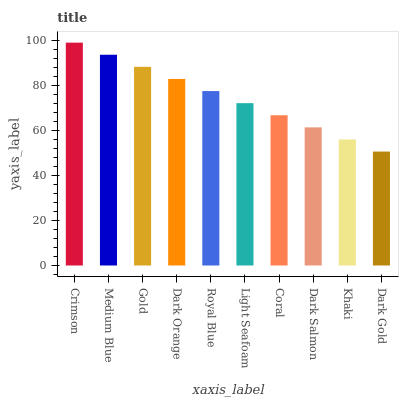Is Dark Gold the minimum?
Answer yes or no. Yes. Is Crimson the maximum?
Answer yes or no. Yes. Is Medium Blue the minimum?
Answer yes or no. No. Is Medium Blue the maximum?
Answer yes or no. No. Is Crimson greater than Medium Blue?
Answer yes or no. Yes. Is Medium Blue less than Crimson?
Answer yes or no. Yes. Is Medium Blue greater than Crimson?
Answer yes or no. No. Is Crimson less than Medium Blue?
Answer yes or no. No. Is Royal Blue the high median?
Answer yes or no. Yes. Is Light Seafoam the low median?
Answer yes or no. Yes. Is Crimson the high median?
Answer yes or no. No. Is Crimson the low median?
Answer yes or no. No. 